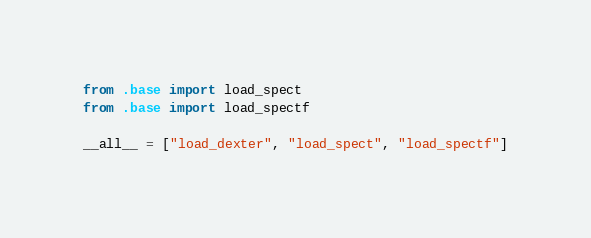<code> <loc_0><loc_0><loc_500><loc_500><_Python_>from .base import load_spect
from .base import load_spectf

__all__ = ["load_dexter", "load_spect", "load_spectf"]
</code> 